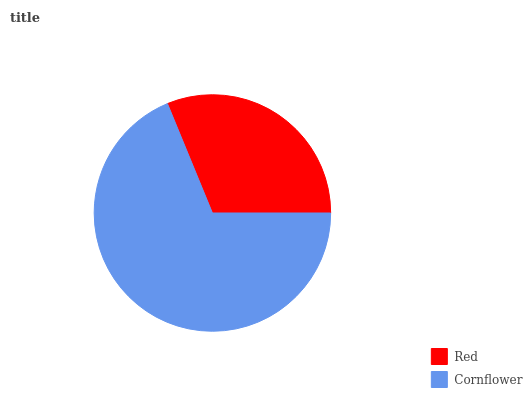Is Red the minimum?
Answer yes or no. Yes. Is Cornflower the maximum?
Answer yes or no. Yes. Is Cornflower the minimum?
Answer yes or no. No. Is Cornflower greater than Red?
Answer yes or no. Yes. Is Red less than Cornflower?
Answer yes or no. Yes. Is Red greater than Cornflower?
Answer yes or no. No. Is Cornflower less than Red?
Answer yes or no. No. Is Cornflower the high median?
Answer yes or no. Yes. Is Red the low median?
Answer yes or no. Yes. Is Red the high median?
Answer yes or no. No. Is Cornflower the low median?
Answer yes or no. No. 